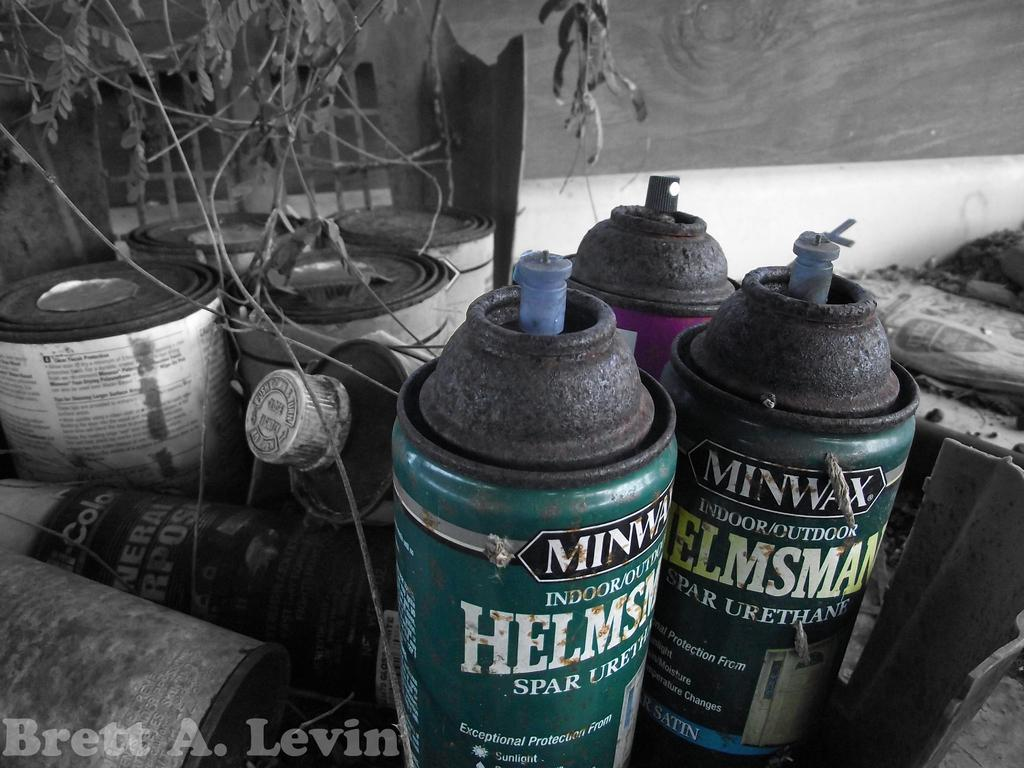<image>
Write a terse but informative summary of the picture. Several cans of MINWAX indoor / outdoor Helmsman paint 